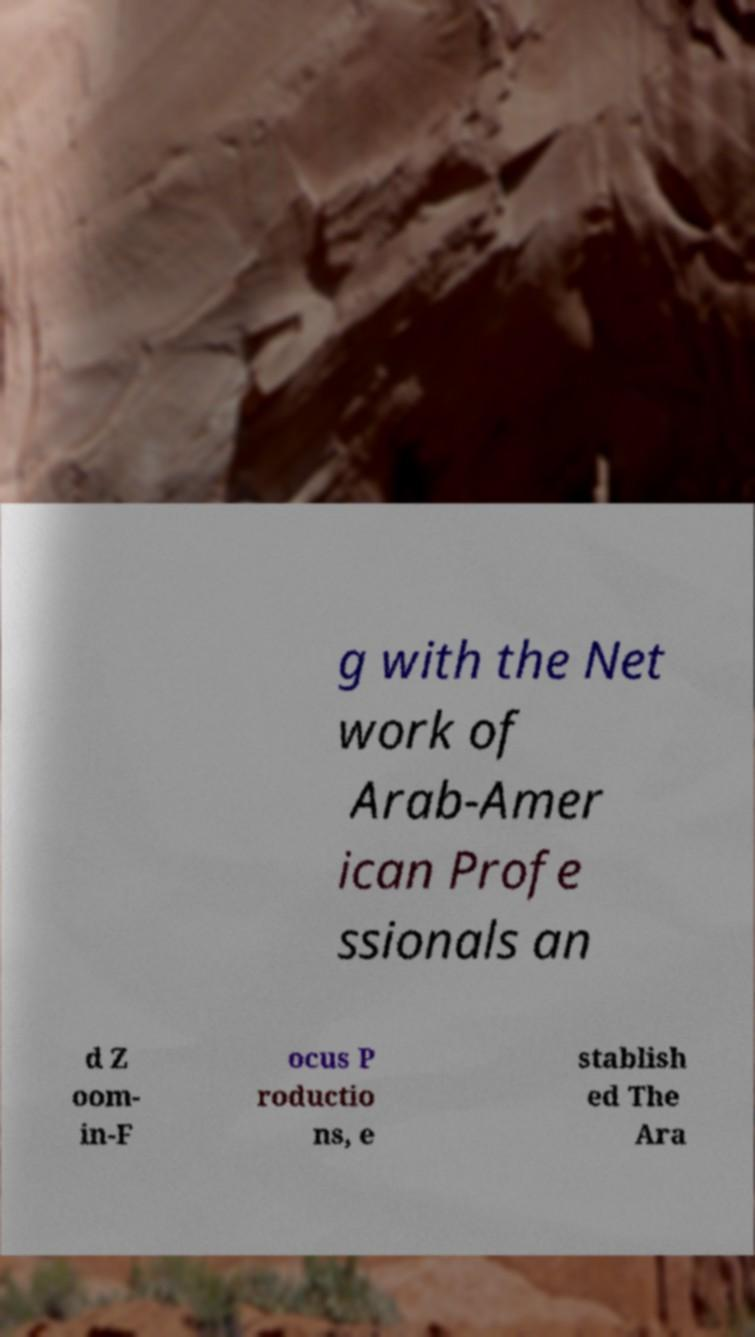Please read and relay the text visible in this image. What does it say? g with the Net work of Arab-Amer ican Profe ssionals an d Z oom- in-F ocus P roductio ns, e stablish ed The Ara 